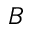<formula> <loc_0><loc_0><loc_500><loc_500>B</formula> 